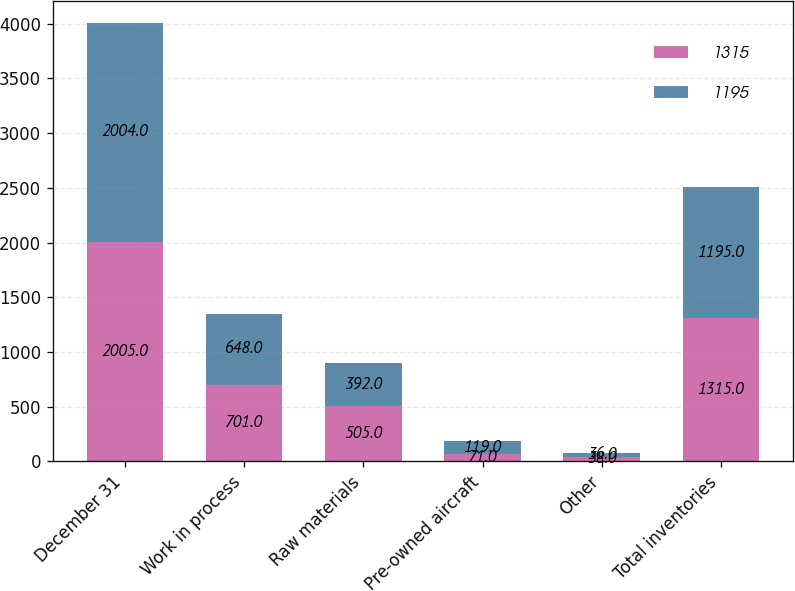<chart> <loc_0><loc_0><loc_500><loc_500><stacked_bar_chart><ecel><fcel>December 31<fcel>Work in process<fcel>Raw materials<fcel>Pre-owned aircraft<fcel>Other<fcel>Total inventories<nl><fcel>1315<fcel>2005<fcel>701<fcel>505<fcel>71<fcel>38<fcel>1315<nl><fcel>1195<fcel>2004<fcel>648<fcel>392<fcel>119<fcel>36<fcel>1195<nl></chart> 